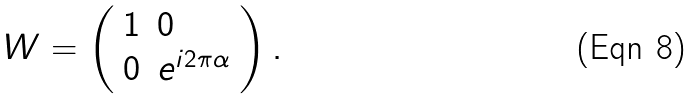Convert formula to latex. <formula><loc_0><loc_0><loc_500><loc_500>W = \left ( \begin{array} { l l } 1 & 0 \\ 0 & e ^ { i 2 \pi \alpha } \end{array} \right ) .</formula> 